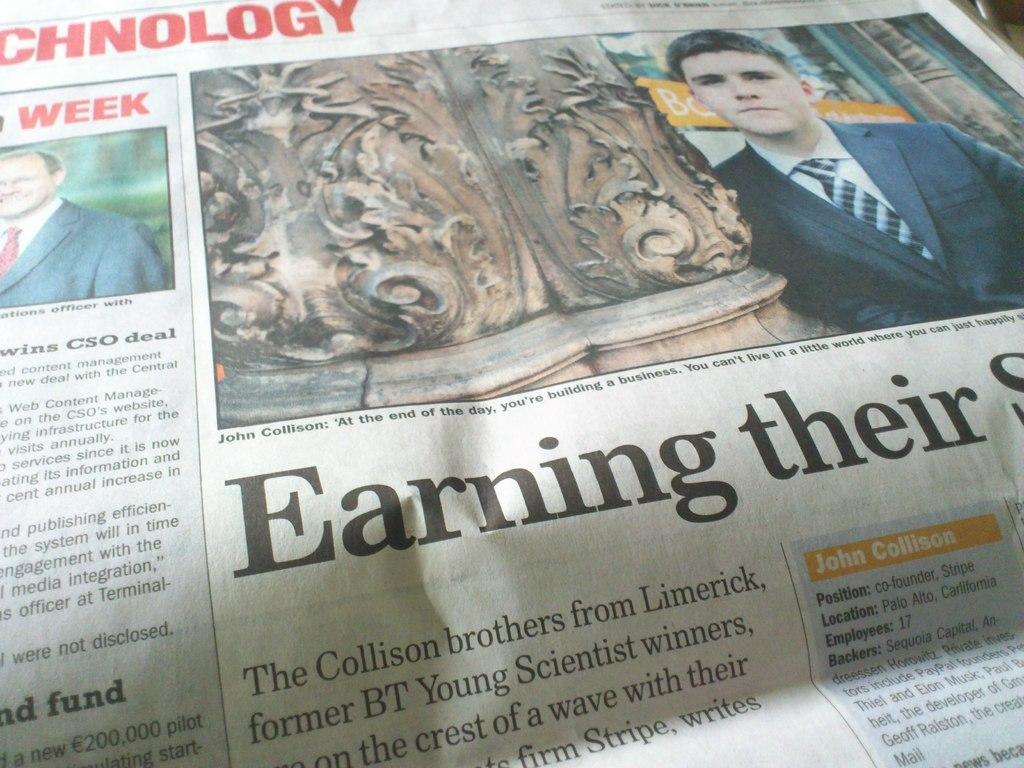How would you summarize this image in a sentence or two? In this image we can see the newspaper. And we can see some text on it. And we can see two men. And we can one pillar. 